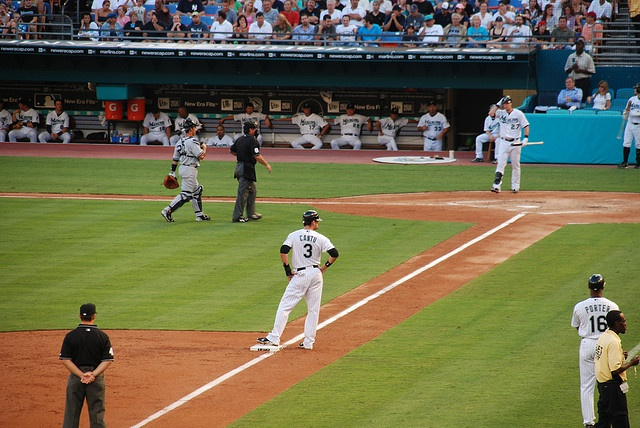Describe the objects in this image and their specific colors. I can see people in darkblue, black, gray, darkgray, and brown tones, people in darkblue, lightgray, darkgray, black, and olive tones, people in darkblue, black, maroon, gray, and brown tones, people in darkblue, black, and tan tones, and bench in darkblue, black, and gray tones in this image. 